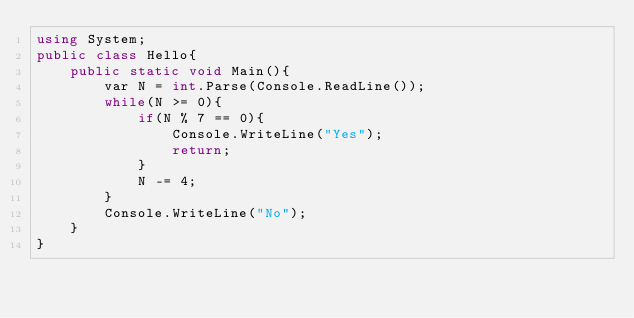<code> <loc_0><loc_0><loc_500><loc_500><_C#_>using System;
public class Hello{
    public static void Main(){
        var N = int.Parse(Console.ReadLine());
        while(N >= 0){
            if(N % 7 == 0){
                Console.WriteLine("Yes");
                return;
            }
            N -= 4;
        }
        Console.WriteLine("No");
    }
}
</code> 